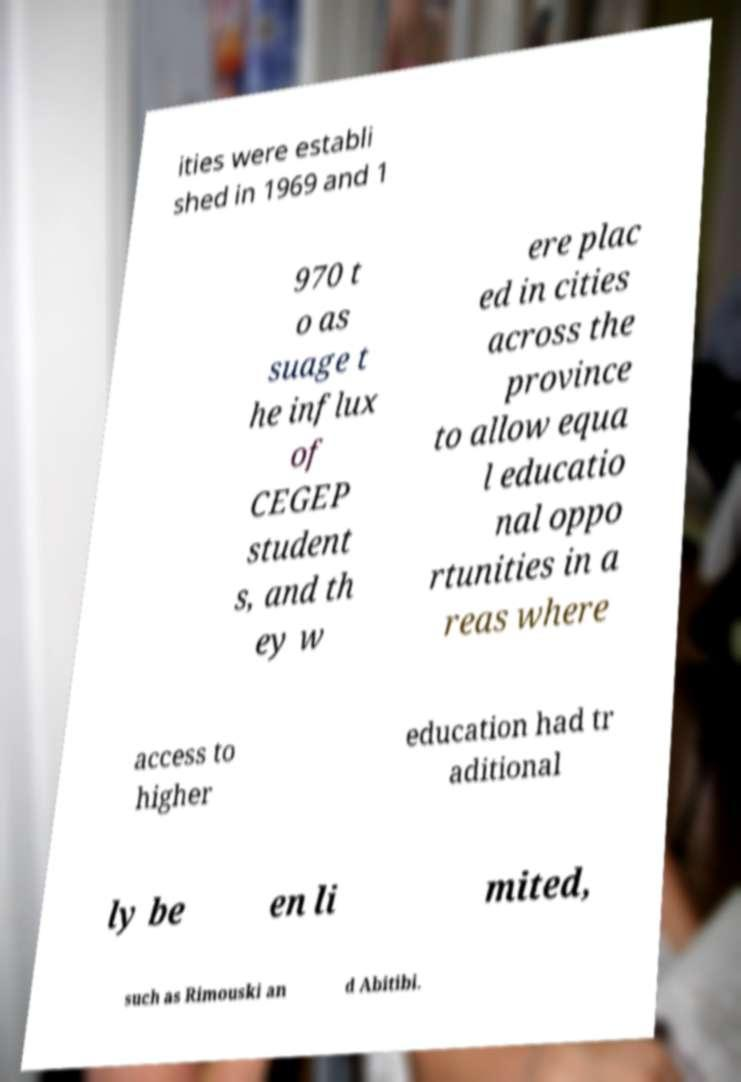Please read and relay the text visible in this image. What does it say? ities were establi shed in 1969 and 1 970 t o as suage t he influx of CEGEP student s, and th ey w ere plac ed in cities across the province to allow equa l educatio nal oppo rtunities in a reas where access to higher education had tr aditional ly be en li mited, such as Rimouski an d Abitibi. 